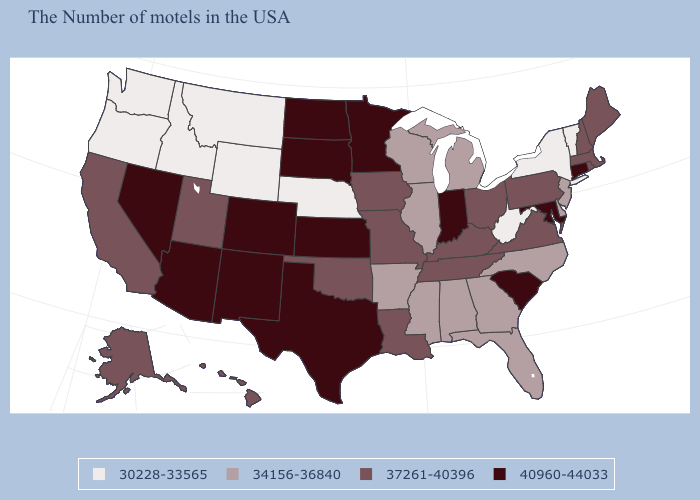Name the states that have a value in the range 37261-40396?
Be succinct. Maine, Massachusetts, Rhode Island, New Hampshire, Pennsylvania, Virginia, Ohio, Kentucky, Tennessee, Louisiana, Missouri, Iowa, Oklahoma, Utah, California, Alaska, Hawaii. What is the value of Delaware?
Keep it brief. 34156-36840. Which states have the highest value in the USA?
Keep it brief. Connecticut, Maryland, South Carolina, Indiana, Minnesota, Kansas, Texas, South Dakota, North Dakota, Colorado, New Mexico, Arizona, Nevada. What is the lowest value in states that border Tennessee?
Answer briefly. 34156-36840. Which states have the lowest value in the USA?
Be succinct. Vermont, New York, West Virginia, Nebraska, Wyoming, Montana, Idaho, Washington, Oregon. Name the states that have a value in the range 30228-33565?
Short answer required. Vermont, New York, West Virginia, Nebraska, Wyoming, Montana, Idaho, Washington, Oregon. Among the states that border Wisconsin , does Michigan have the lowest value?
Keep it brief. Yes. What is the lowest value in states that border California?
Give a very brief answer. 30228-33565. What is the value of Kentucky?
Give a very brief answer. 37261-40396. What is the highest value in states that border New York?
Short answer required. 40960-44033. Does the map have missing data?
Short answer required. No. Name the states that have a value in the range 40960-44033?
Concise answer only. Connecticut, Maryland, South Carolina, Indiana, Minnesota, Kansas, Texas, South Dakota, North Dakota, Colorado, New Mexico, Arizona, Nevada. What is the value of Montana?
Answer briefly. 30228-33565. Among the states that border North Carolina , which have the highest value?
Write a very short answer. South Carolina. 